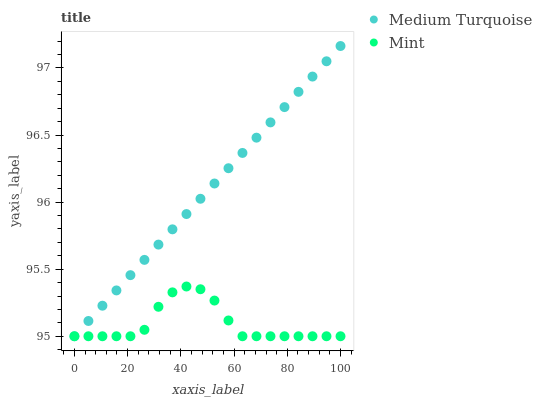Does Mint have the minimum area under the curve?
Answer yes or no. Yes. Does Medium Turquoise have the maximum area under the curve?
Answer yes or no. Yes. Does Medium Turquoise have the minimum area under the curve?
Answer yes or no. No. Is Medium Turquoise the smoothest?
Answer yes or no. Yes. Is Mint the roughest?
Answer yes or no. Yes. Is Medium Turquoise the roughest?
Answer yes or no. No. Does Mint have the lowest value?
Answer yes or no. Yes. Does Medium Turquoise have the highest value?
Answer yes or no. Yes. Does Mint intersect Medium Turquoise?
Answer yes or no. Yes. Is Mint less than Medium Turquoise?
Answer yes or no. No. Is Mint greater than Medium Turquoise?
Answer yes or no. No. 